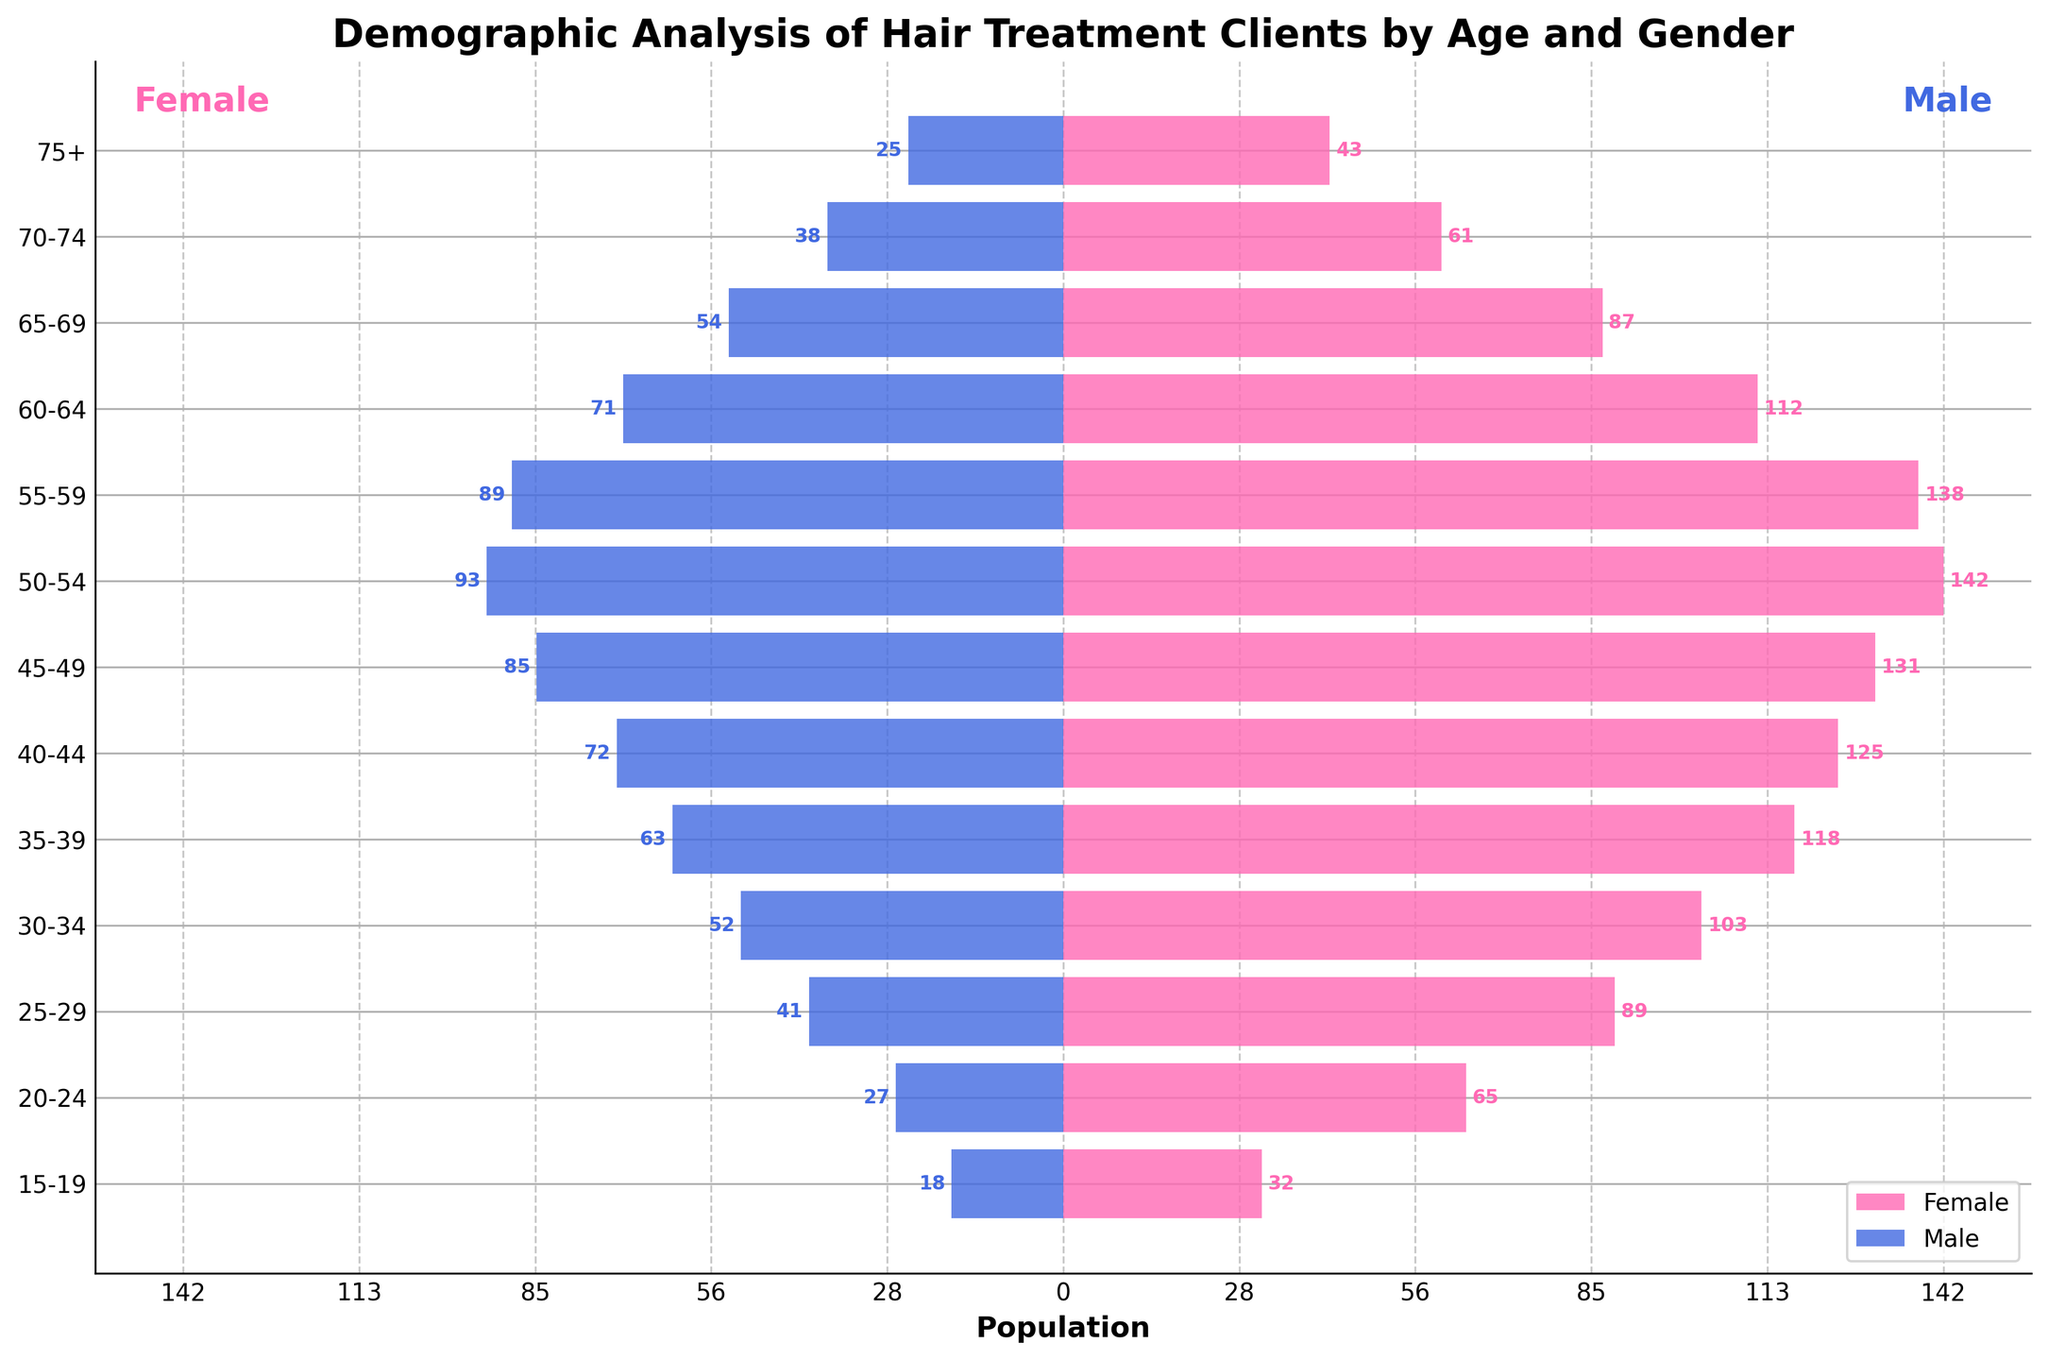What is the title of the figure? The title of a figure is usually located at the top of the plot, summarizing what the chart represents. By observing the figure, the title "Demographic Analysis of Hair Treatment Clients by Age and Gender" is visible at the top.
Answer: Demographic Analysis of Hair Treatment Clients by Age and Gender Which age group has the highest number of female clients? To determine the age group with the highest number of female clients, look at the longest bar on the female side (left side, pink color). The longest bar corresponds to the '50-54' age group with 142 female clients.
Answer: 50-54 What is the sum of male clients in the age groups 45-49 and 50-54? First, identify the number of male clients in the 45-49 (85) and 50-54 (93) age groups. Add these numbers together: 85 + 93 = 178.
Answer: 178 How does the number of female clients in the 35-39 age group compare to the number of male clients in the same age group? The number of female clients in the 35-39 age group is 118 and the number of male clients is 63. By comparing the two, 118 female clients are greater than 63 male clients.
Answer: Female clients are greater Which gender has a higher number of clients in the 30-34 age group and by how much? To find out, compare the number of clients for each gender within the 30-34 age group: 103 female clients and 52 male clients. Calculate the difference: 103 - 52 = 51.
Answer: Female by 51 What is the average number of female clients for the age groups 25-34? Find the number of female clients in the age groups 25-29 (89) and 30-34 (103). Sum these values: 89 + 103 = 192. Divide by 2 (number of age groups): 192 / 2 = 96.
Answer: 96 For which age group is the difference between the number of male and female clients the greatest? Calculate the differences for each age group and find the largest one: For 50-54: 142-93=49, for 45-49: 131-85=46. The greatest difference is 49 in the 50-54 age group.
Answer: 50-54 What's the total number of clients aged 60 and above? Sum the clients (both genders) for the age groups 60-64, 65-69, 70-74, and 75+. For female: 112 + 87 + 61 + 43 = 303. For male: 71 + 54 + 38 + 25 = 188. Total: 303 + 188 = 491.
Answer: 491 What percent of the 25-29 age group clients are male? First, find the total number of clients in this age group: 89 (female) + 41 (male) = 130. Then, calculate the percentage: (41/130) * 100 ≈ 31.54%.
Answer: 31.54% What three age groups have the smallest gap between male and female clients? Calculate the differences for each age group, then find the three smallest: 75+ (18), 70-74 (23), and 60-64 (41).
Answer: 75+, 70-74, 60-64 